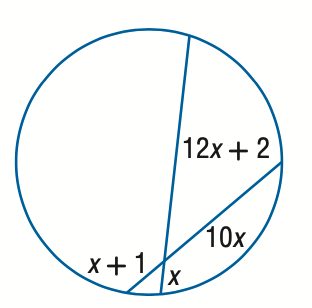Question: Find x. Assume that segments that appear to be tangent are tangent.
Choices:
A. 2
B. 3
C. 4
D. 5
Answer with the letter. Answer: C 